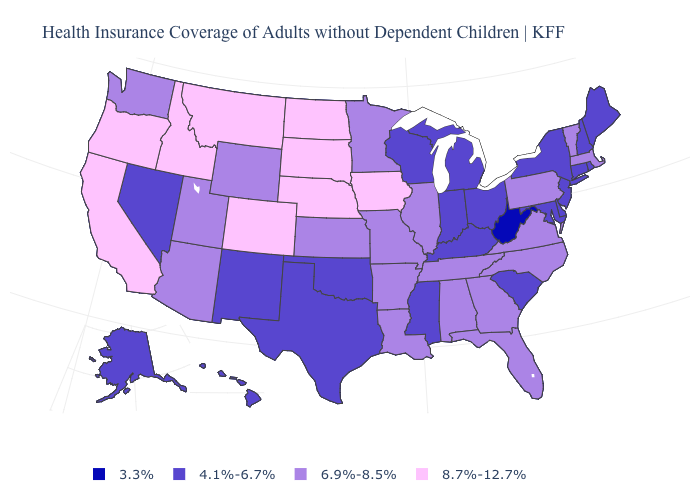Name the states that have a value in the range 4.1%-6.7%?
Short answer required. Alaska, Connecticut, Delaware, Hawaii, Indiana, Kentucky, Maine, Maryland, Michigan, Mississippi, Nevada, New Hampshire, New Jersey, New Mexico, New York, Ohio, Oklahoma, Rhode Island, South Carolina, Texas, Wisconsin. What is the value of West Virginia?
Quick response, please. 3.3%. What is the lowest value in states that border Connecticut?
Give a very brief answer. 4.1%-6.7%. Does Vermont have the same value as Nebraska?
Keep it brief. No. Does Washington have the same value as Florida?
Concise answer only. Yes. What is the value of Pennsylvania?
Be succinct. 6.9%-8.5%. Among the states that border Illinois , which have the highest value?
Concise answer only. Iowa. Name the states that have a value in the range 4.1%-6.7%?
Be succinct. Alaska, Connecticut, Delaware, Hawaii, Indiana, Kentucky, Maine, Maryland, Michigan, Mississippi, Nevada, New Hampshire, New Jersey, New Mexico, New York, Ohio, Oklahoma, Rhode Island, South Carolina, Texas, Wisconsin. What is the value of Arizona?
Keep it brief. 6.9%-8.5%. What is the value of West Virginia?
Write a very short answer. 3.3%. Among the states that border Ohio , which have the highest value?
Give a very brief answer. Pennsylvania. Name the states that have a value in the range 4.1%-6.7%?
Keep it brief. Alaska, Connecticut, Delaware, Hawaii, Indiana, Kentucky, Maine, Maryland, Michigan, Mississippi, Nevada, New Hampshire, New Jersey, New Mexico, New York, Ohio, Oklahoma, Rhode Island, South Carolina, Texas, Wisconsin. What is the lowest value in the West?
Give a very brief answer. 4.1%-6.7%. Which states have the lowest value in the USA?
Be succinct. West Virginia. 